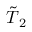Convert formula to latex. <formula><loc_0><loc_0><loc_500><loc_500>\tilde { T } _ { 2 }</formula> 